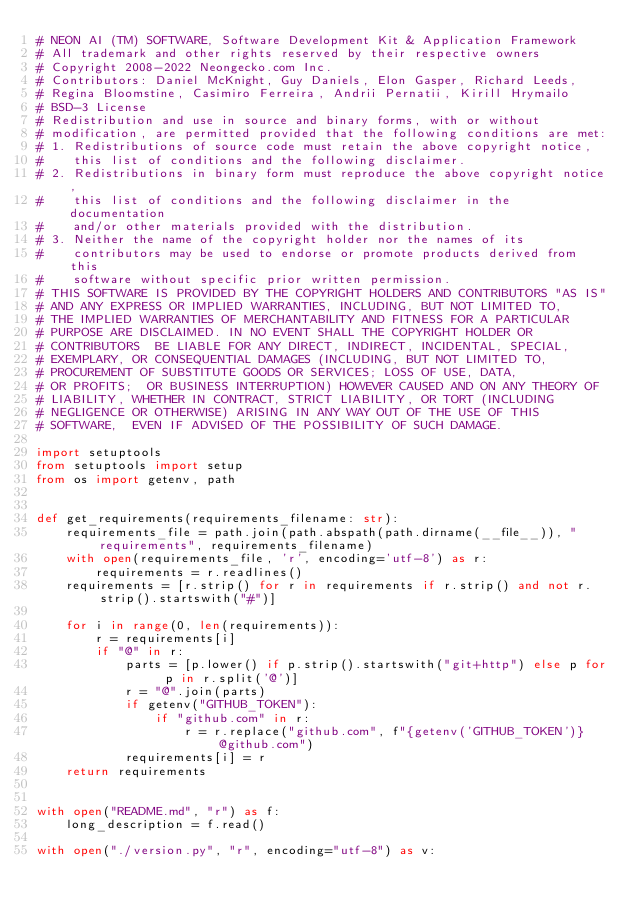<code> <loc_0><loc_0><loc_500><loc_500><_Python_># NEON AI (TM) SOFTWARE, Software Development Kit & Application Framework
# All trademark and other rights reserved by their respective owners
# Copyright 2008-2022 Neongecko.com Inc.
# Contributors: Daniel McKnight, Guy Daniels, Elon Gasper, Richard Leeds,
# Regina Bloomstine, Casimiro Ferreira, Andrii Pernatii, Kirill Hrymailo
# BSD-3 License
# Redistribution and use in source and binary forms, with or without
# modification, are permitted provided that the following conditions are met:
# 1. Redistributions of source code must retain the above copyright notice,
#    this list of conditions and the following disclaimer.
# 2. Redistributions in binary form must reproduce the above copyright notice,
#    this list of conditions and the following disclaimer in the documentation
#    and/or other materials provided with the distribution.
# 3. Neither the name of the copyright holder nor the names of its
#    contributors may be used to endorse or promote products derived from this
#    software without specific prior written permission.
# THIS SOFTWARE IS PROVIDED BY THE COPYRIGHT HOLDERS AND CONTRIBUTORS "AS IS"
# AND ANY EXPRESS OR IMPLIED WARRANTIES, INCLUDING, BUT NOT LIMITED TO,
# THE IMPLIED WARRANTIES OF MERCHANTABILITY AND FITNESS FOR A PARTICULAR
# PURPOSE ARE DISCLAIMED. IN NO EVENT SHALL THE COPYRIGHT HOLDER OR
# CONTRIBUTORS  BE LIABLE FOR ANY DIRECT, INDIRECT, INCIDENTAL, SPECIAL,
# EXEMPLARY, OR CONSEQUENTIAL DAMAGES (INCLUDING, BUT NOT LIMITED TO,
# PROCUREMENT OF SUBSTITUTE GOODS OR SERVICES; LOSS OF USE, DATA,
# OR PROFITS;  OR BUSINESS INTERRUPTION) HOWEVER CAUSED AND ON ANY THEORY OF
# LIABILITY, WHETHER IN CONTRACT, STRICT LIABILITY, OR TORT (INCLUDING
# NEGLIGENCE OR OTHERWISE) ARISING IN ANY WAY OUT OF THE USE OF THIS
# SOFTWARE,  EVEN IF ADVISED OF THE POSSIBILITY OF SUCH DAMAGE.

import setuptools
from setuptools import setup
from os import getenv, path


def get_requirements(requirements_filename: str):
    requirements_file = path.join(path.abspath(path.dirname(__file__)), "requirements", requirements_filename)
    with open(requirements_file, 'r', encoding='utf-8') as r:
        requirements = r.readlines()
    requirements = [r.strip() for r in requirements if r.strip() and not r.strip().startswith("#")]

    for i in range(0, len(requirements)):
        r = requirements[i]
        if "@" in r:
            parts = [p.lower() if p.strip().startswith("git+http") else p for p in r.split('@')]
            r = "@".join(parts)
            if getenv("GITHUB_TOKEN"):
                if "github.com" in r:
                    r = r.replace("github.com", f"{getenv('GITHUB_TOKEN')}@github.com")
            requirements[i] = r
    return requirements


with open("README.md", "r") as f:
    long_description = f.read()

with open("./version.py", "r", encoding="utf-8") as v:</code> 